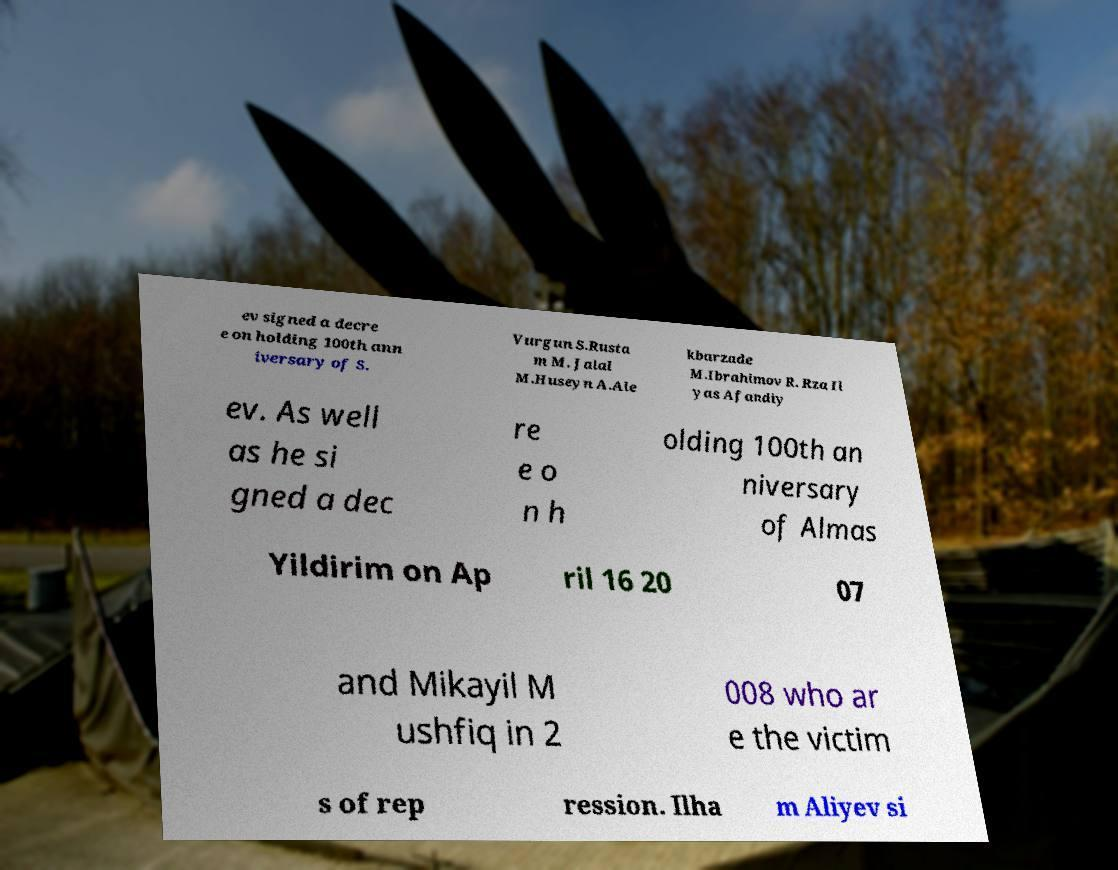Could you assist in decoding the text presented in this image and type it out clearly? ev signed a decre e on holding 100th ann iversary of S. Vurgun S.Rusta m M. Jalal M.Huseyn A.Ale kbarzade M.Ibrahimov R. Rza Il yas Afandiy ev. As well as he si gned a dec re e o n h olding 100th an niversary of Almas Yildirim on Ap ril 16 20 07 and Mikayil M ushfiq in 2 008 who ar e the victim s of rep ression. Ilha m Aliyev si 